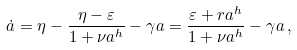Convert formula to latex. <formula><loc_0><loc_0><loc_500><loc_500>\dot { a } = \eta - \frac { \eta - \varepsilon } { 1 + \nu a ^ { h } } - \gamma a = \frac { \varepsilon + r a ^ { h } } { 1 + \nu a ^ { h } } - \gamma a \, ,</formula> 